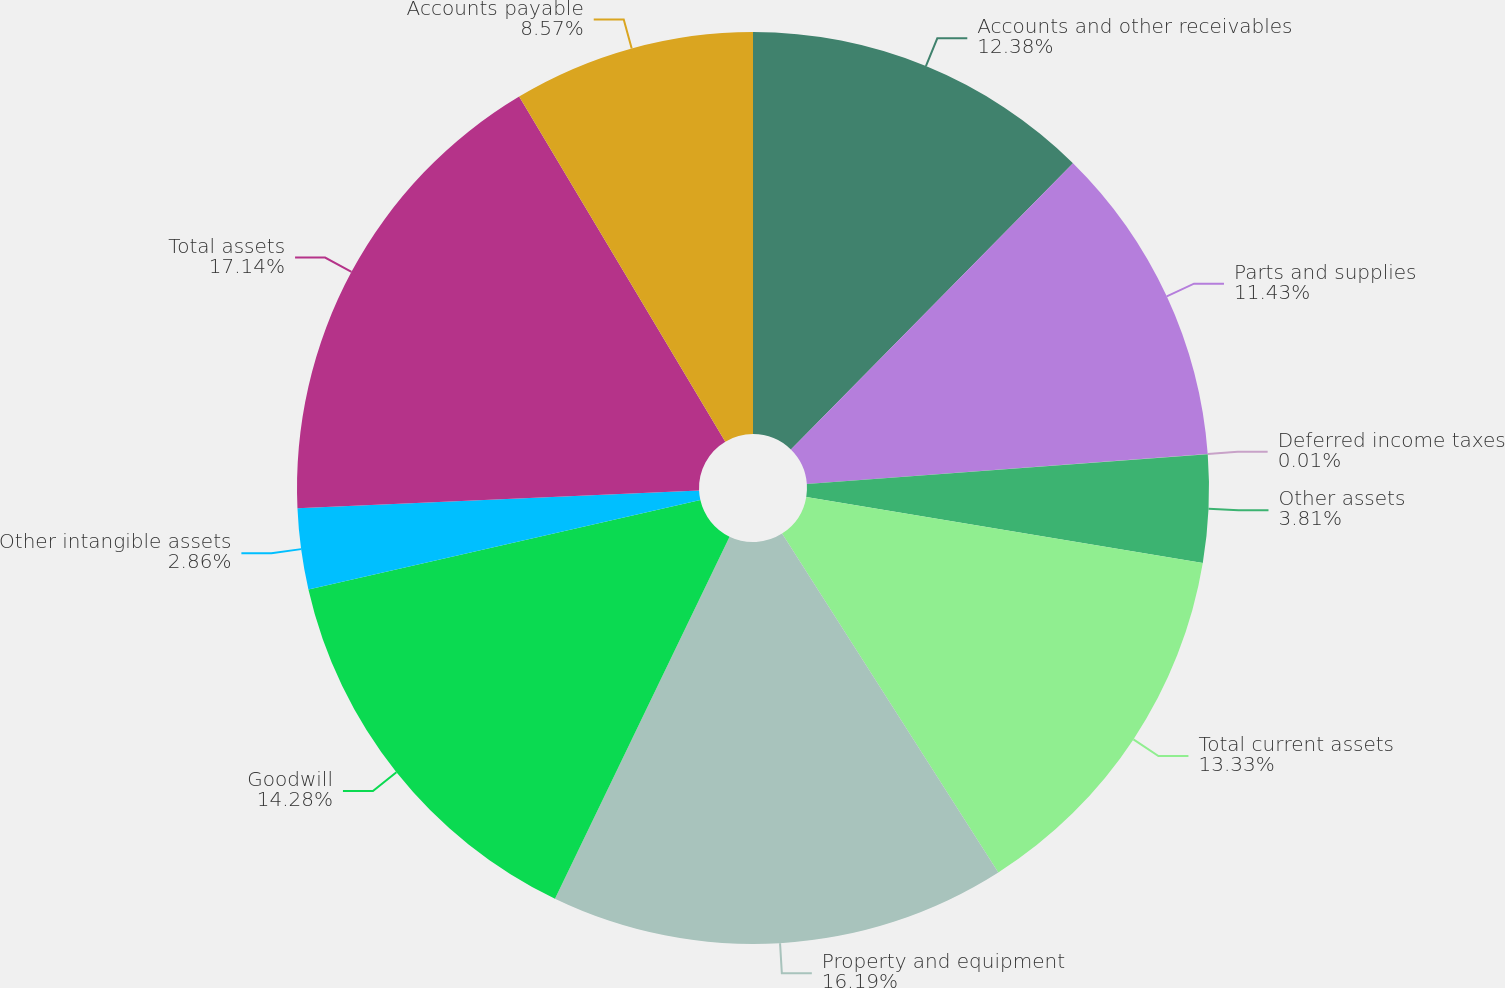Convert chart. <chart><loc_0><loc_0><loc_500><loc_500><pie_chart><fcel>Accounts and other receivables<fcel>Parts and supplies<fcel>Deferred income taxes<fcel>Other assets<fcel>Total current assets<fcel>Property and equipment<fcel>Goodwill<fcel>Other intangible assets<fcel>Total assets<fcel>Accounts payable<nl><fcel>12.38%<fcel>11.43%<fcel>0.01%<fcel>3.81%<fcel>13.33%<fcel>16.19%<fcel>14.28%<fcel>2.86%<fcel>17.14%<fcel>8.57%<nl></chart> 